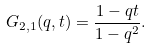Convert formula to latex. <formula><loc_0><loc_0><loc_500><loc_500>G _ { 2 , 1 } ( q , t ) = \frac { 1 - q t } { 1 - q ^ { 2 } } .</formula> 